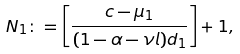<formula> <loc_0><loc_0><loc_500><loc_500>N _ { 1 } \colon = \left [ \frac { c - \mu _ { 1 } } { ( 1 - \alpha - \nu l ) d _ { 1 } } \right ] + 1 ,</formula> 